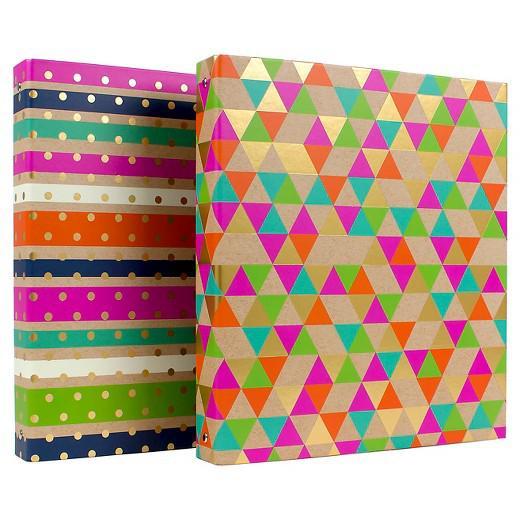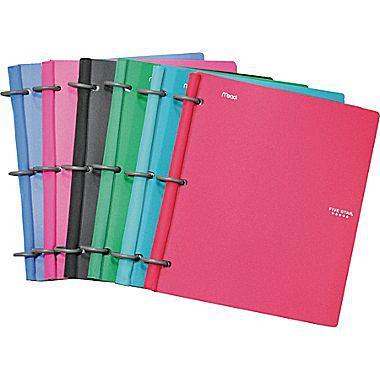The first image is the image on the left, the second image is the image on the right. Analyze the images presented: Is the assertion "At least one of the binders is open." valid? Answer yes or no. No. The first image is the image on the left, the second image is the image on the right. Assess this claim about the two images: "One binder is open and showing its prongs.". Correct or not? Answer yes or no. No. 